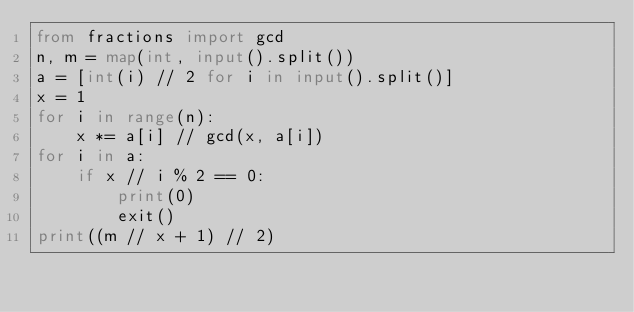Convert code to text. <code><loc_0><loc_0><loc_500><loc_500><_Python_>from fractions import gcd
n, m = map(int, input().split())
a = [int(i) // 2 for i in input().split()]
x = 1
for i in range(n):
    x *= a[i] // gcd(x, a[i])
for i in a:
    if x // i % 2 == 0:
        print(0)
        exit()
print((m // x + 1) // 2)</code> 